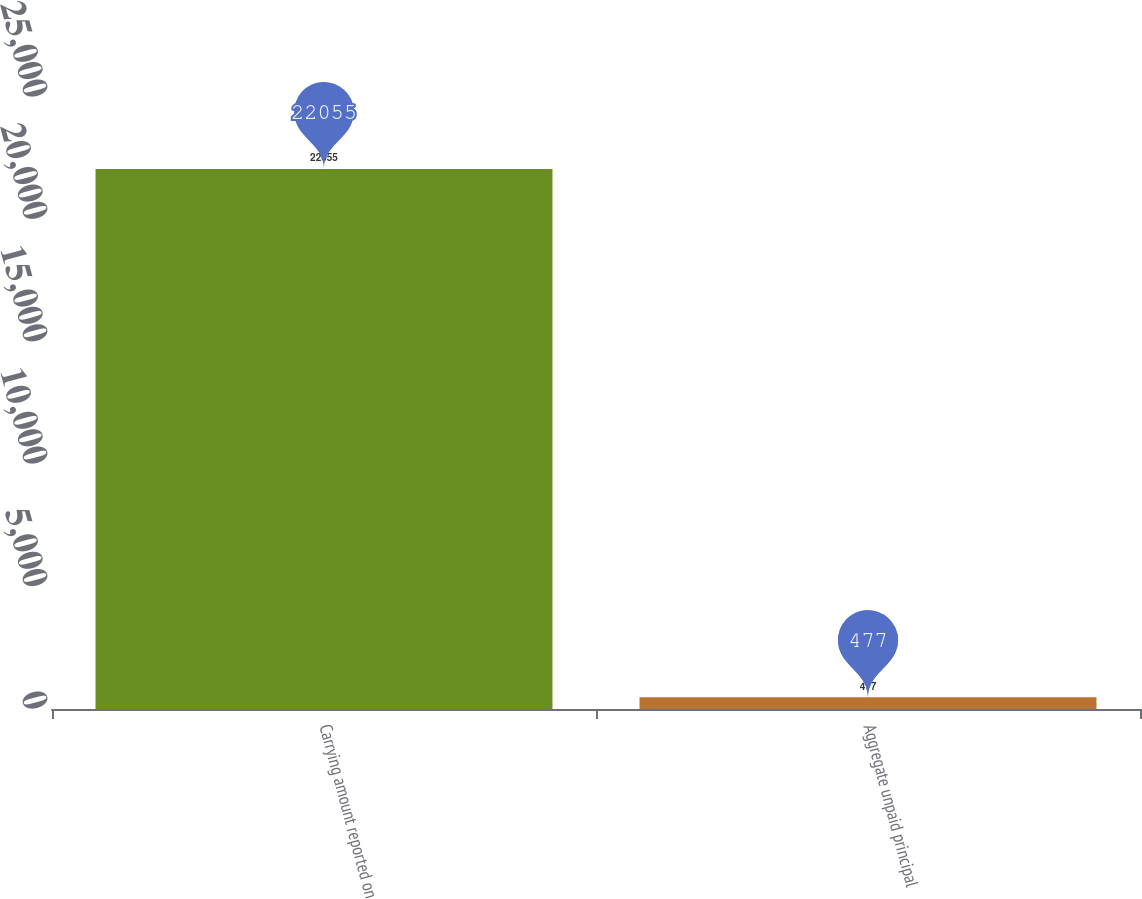<chart> <loc_0><loc_0><loc_500><loc_500><bar_chart><fcel>Carrying amount reported on<fcel>Aggregate unpaid principal<nl><fcel>22055<fcel>477<nl></chart> 